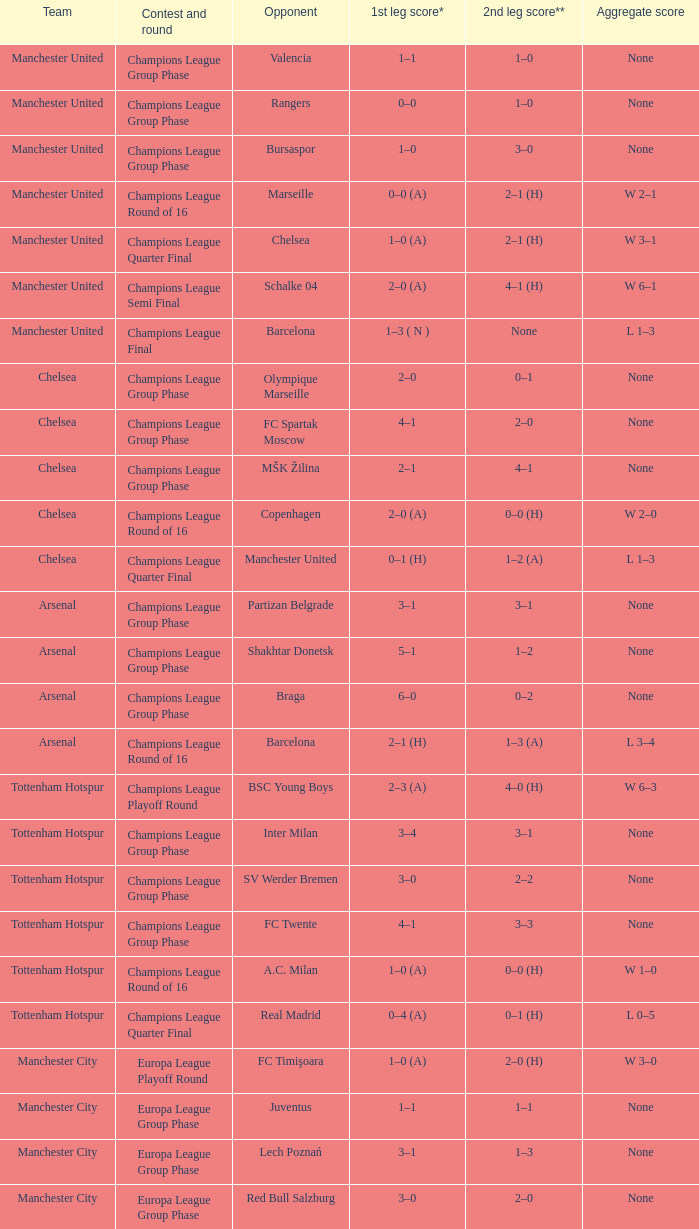What was the score between Marseille and Manchester United on the second leg of the Champions League Round of 16? 2–1 (H). 